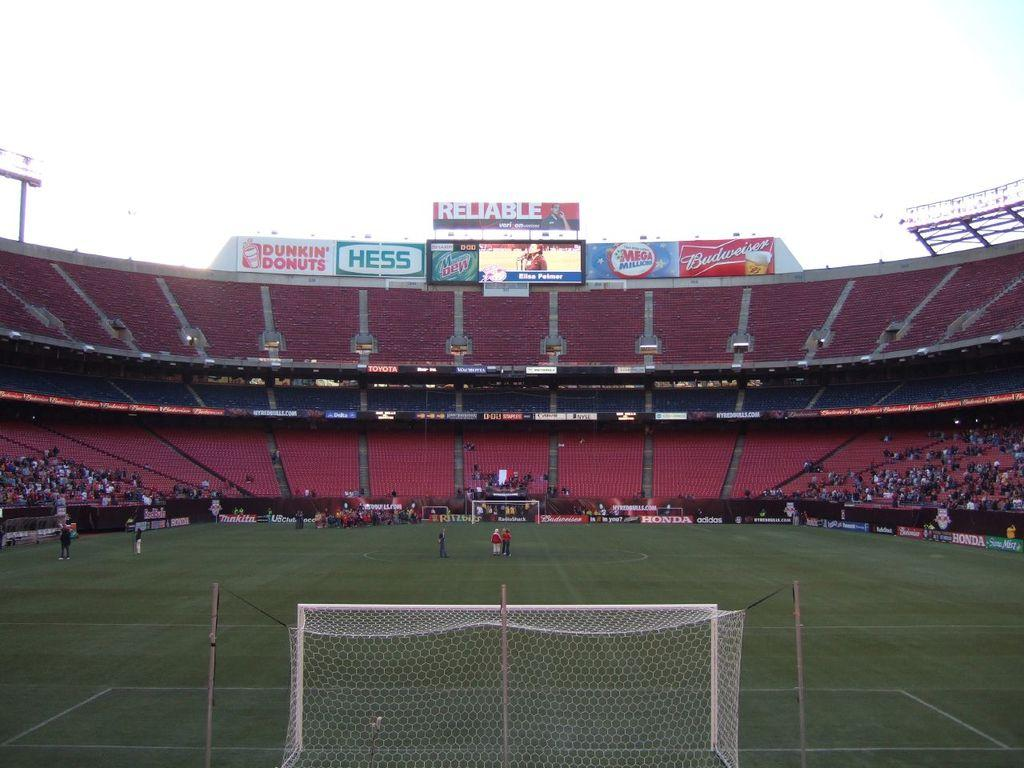<image>
Write a terse but informative summary of the picture. A soccer stadium that is empty with a HESS sign at the top. 